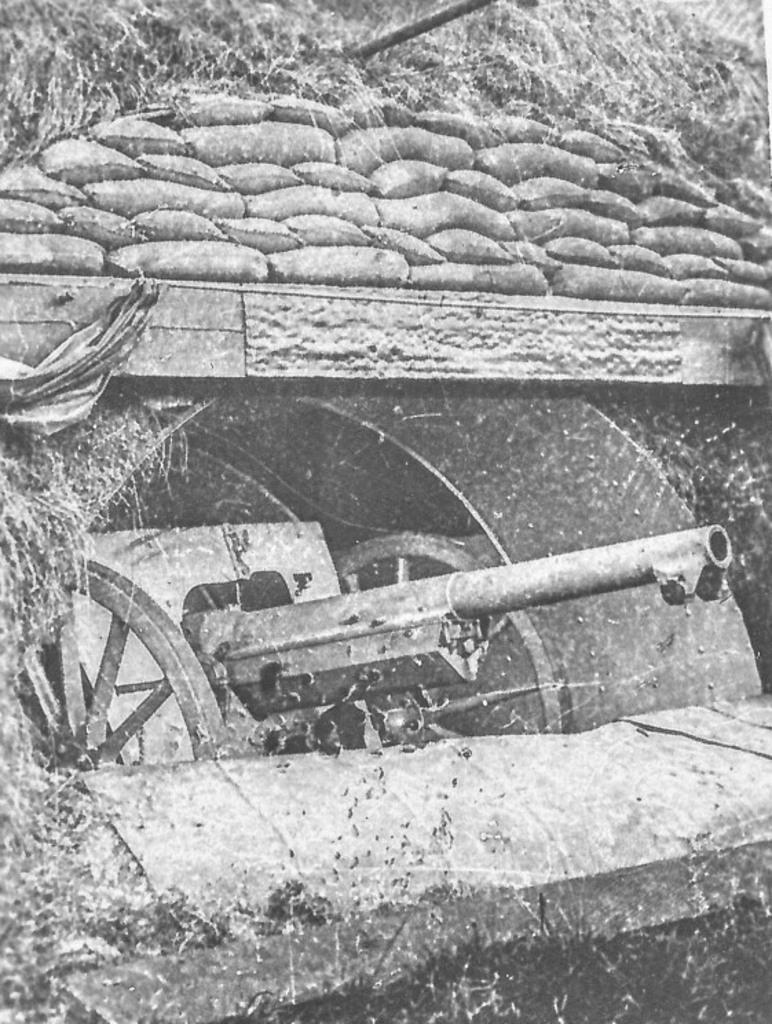What is the color scheme of the image? The image is black and white. What type of vehicle is present in the image? There is a panzer in the image. Where is the panzer located? The panzer is in a tunnel. What can be seen above the panzer? There is a wall above the panzer. What is attached to the wall? There are many sacs on the wall. What type of toys can be seen on the floor in the image? There are no toys visible in the image; it features a panzer in a tunnel with a wall and sacs. 